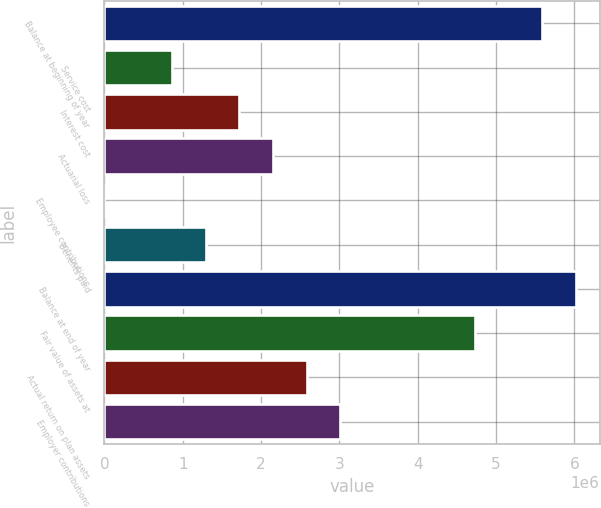Convert chart to OTSL. <chart><loc_0><loc_0><loc_500><loc_500><bar_chart><fcel>Balance at beginning of year<fcel>Service cost<fcel>Interest cost<fcel>Actuarial loss<fcel>Employee contributions<fcel>Benefits paid<fcel>Balance at end of year<fcel>Fair value of assets at<fcel>Actual return on plan assets<fcel>Employer contributions<nl><fcel>5.59132e+06<fcel>860959<fcel>1.72102e+06<fcel>2.15106e+06<fcel>894<fcel>1.29099e+06<fcel>6.02135e+06<fcel>4.73125e+06<fcel>2.58109e+06<fcel>3.01112e+06<nl></chart> 